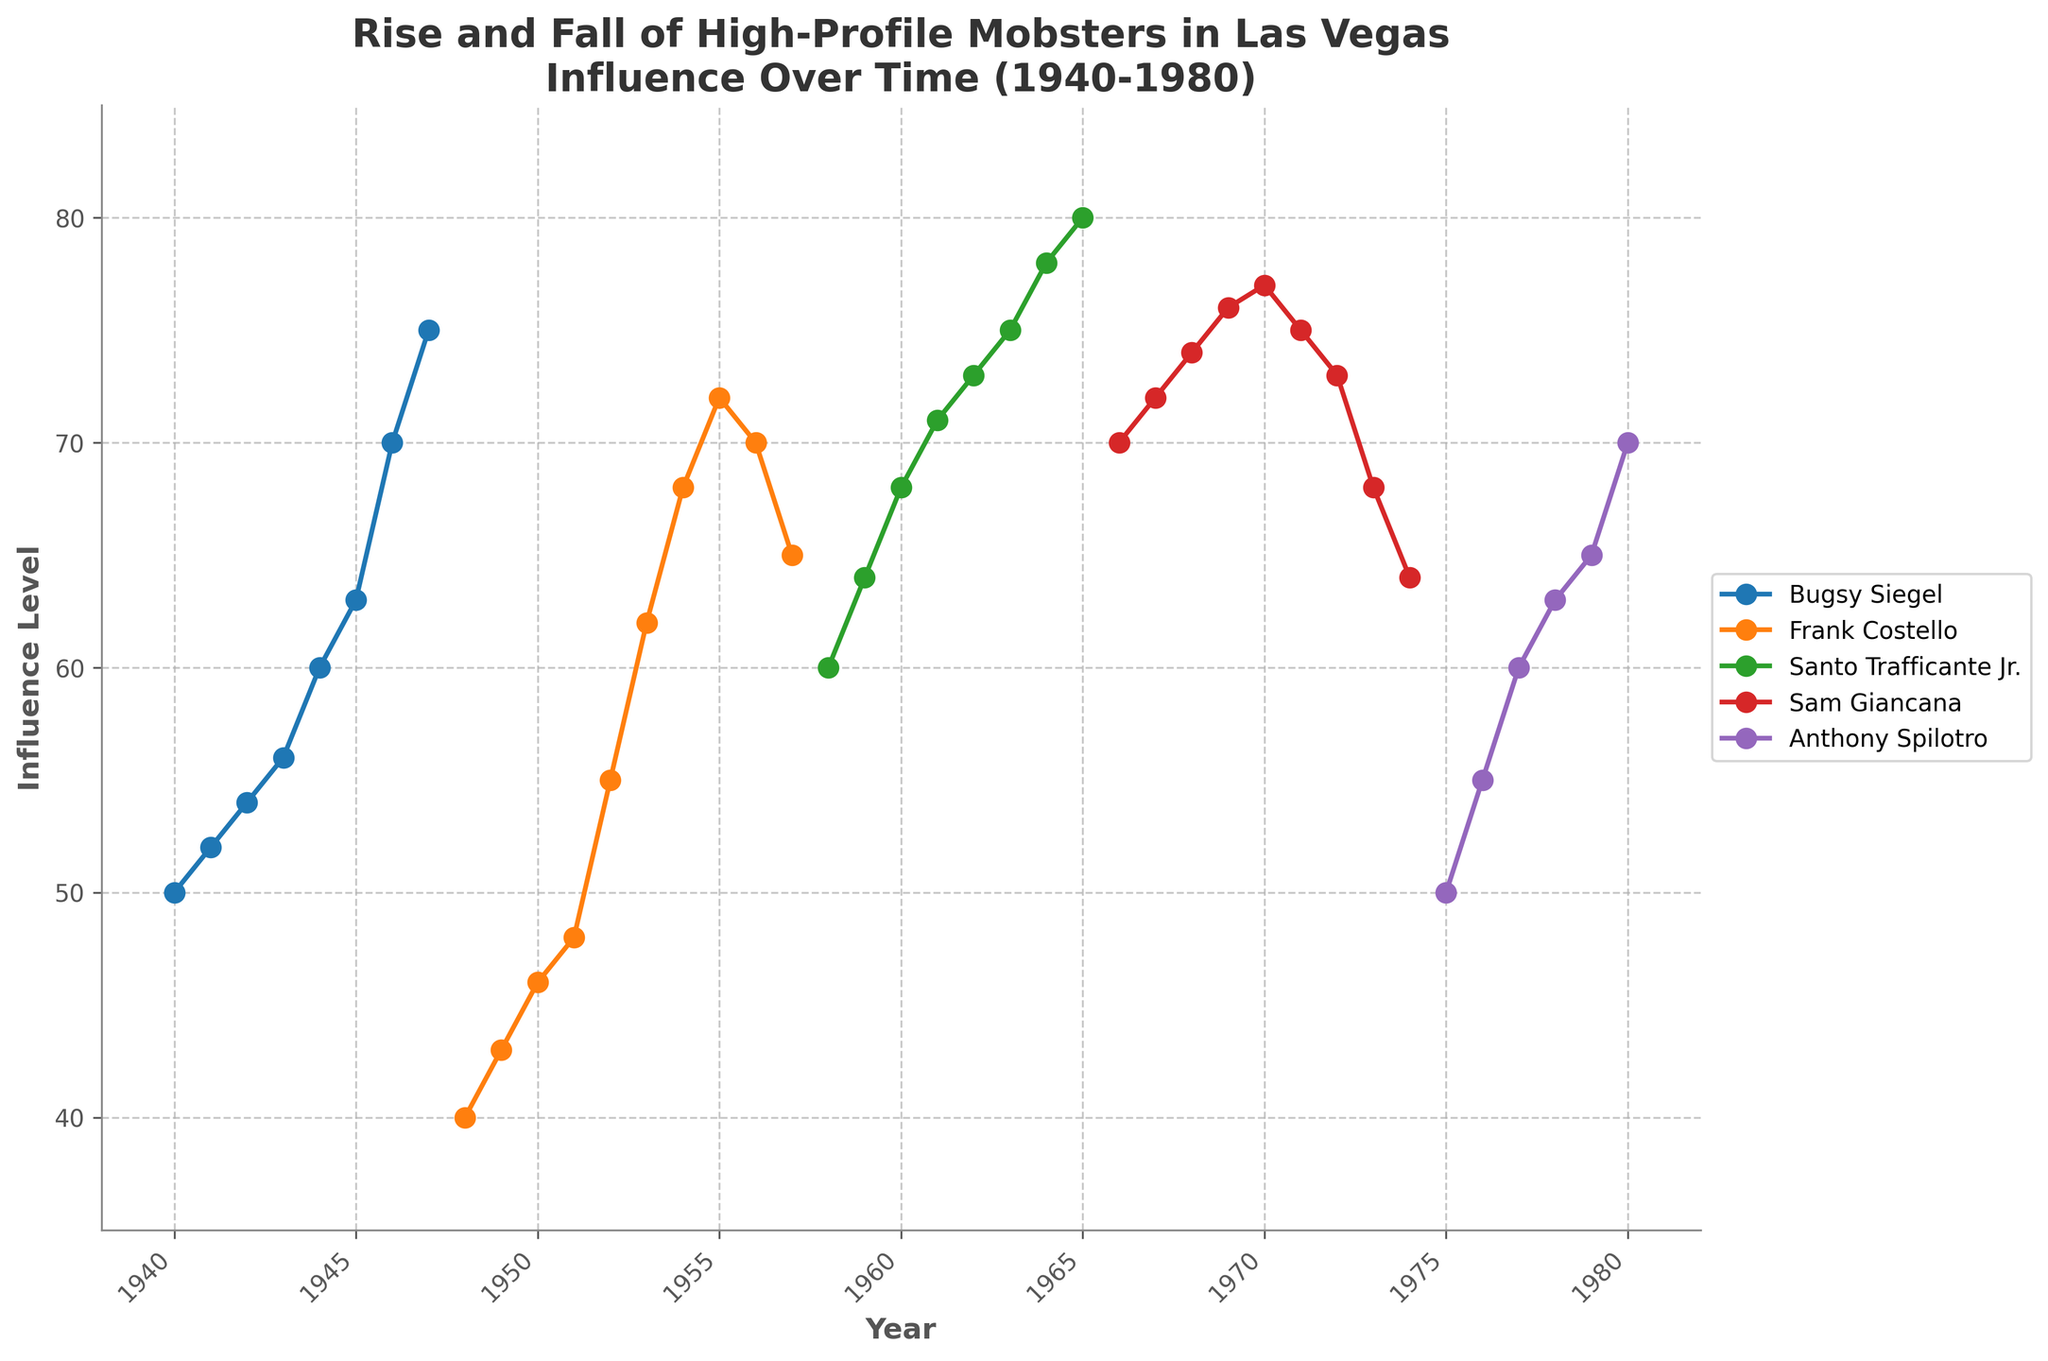What's the overall title of the plot? The title is displayed at the top of the plot. It reads "Rise and Fall of High-Profile Mobsters in Las Vegas: Influence Over Time (1940-1980)".
Answer: Rise and Fall of High-Profile Mobsters in Las Vegas: Influence Over Time (1940-1980) What are the years of Bugsy Siegel's data points? Look for the year values along the X-axis where Bugsy Siegel's line appears. Bugsy Siegel's data points range from 1940 to 1947.
Answer: 1940 to 1947 How did the influence level of Frank Costello change between 1955 and 1957? Look at the data points for Frank Costello between 1955 and 1957. In 1955, the influence level is 72. In 1956, it drops to 70, and in 1957, it decreases further to 65. This indicates a decrease.
Answer: Decreased Describe the trend of Santo Trafficante Jr.'s influence level from 1958 to 1965. Check the influence level points for Santo Trafficante Jr. from 1958 to 1965. His influence increases steadily from 60 in 1958 to 80 in 1965, showing an upward trend.
Answer: Upward trend Which mobster had the highest influence level in 1947? Refer to the plot data for the year 1947. Bugsy Siegel’s influence level is 75, which is the highest compared to any other mobster.
Answer: Bugsy Siegel What is the difference in influence level between Sam Giancana in 1970 and 1973? Check Sam Giancana's influence levels for 1970 (77) and 1973 (68). Calculate the difference: 77 - 68 = 9.
Answer: 9 Which mobster's influence started to decline after reaching a peak in 1972? Look for the mobster whose influence level decreases after 1972. Sam Giancana’s influence peaked in 1970 (77) and began to decline after 1972 (73), dropping further by 1973 (68).
Answer: Sam Giancana Over what time period did Anthony Spilotro's influence increase? Identify the years of Anthony Spilotro’s data points. His influence increases from 50 in 1975 to 70 in 1980. This shows an increasing trend between 1975 and 1980.
Answer: 1975 to 1980 Which mobster had a steady influence level without any decline from 1965 to 1980? Examine the influence data for each mobster from 1965 to 1980. Santo Trafficante Jr. shows a steady or increasing influence from 1965 (80) until 1965, but after that, no other mobster data shows an uninterrupted increase without a decline.
Answer: None 